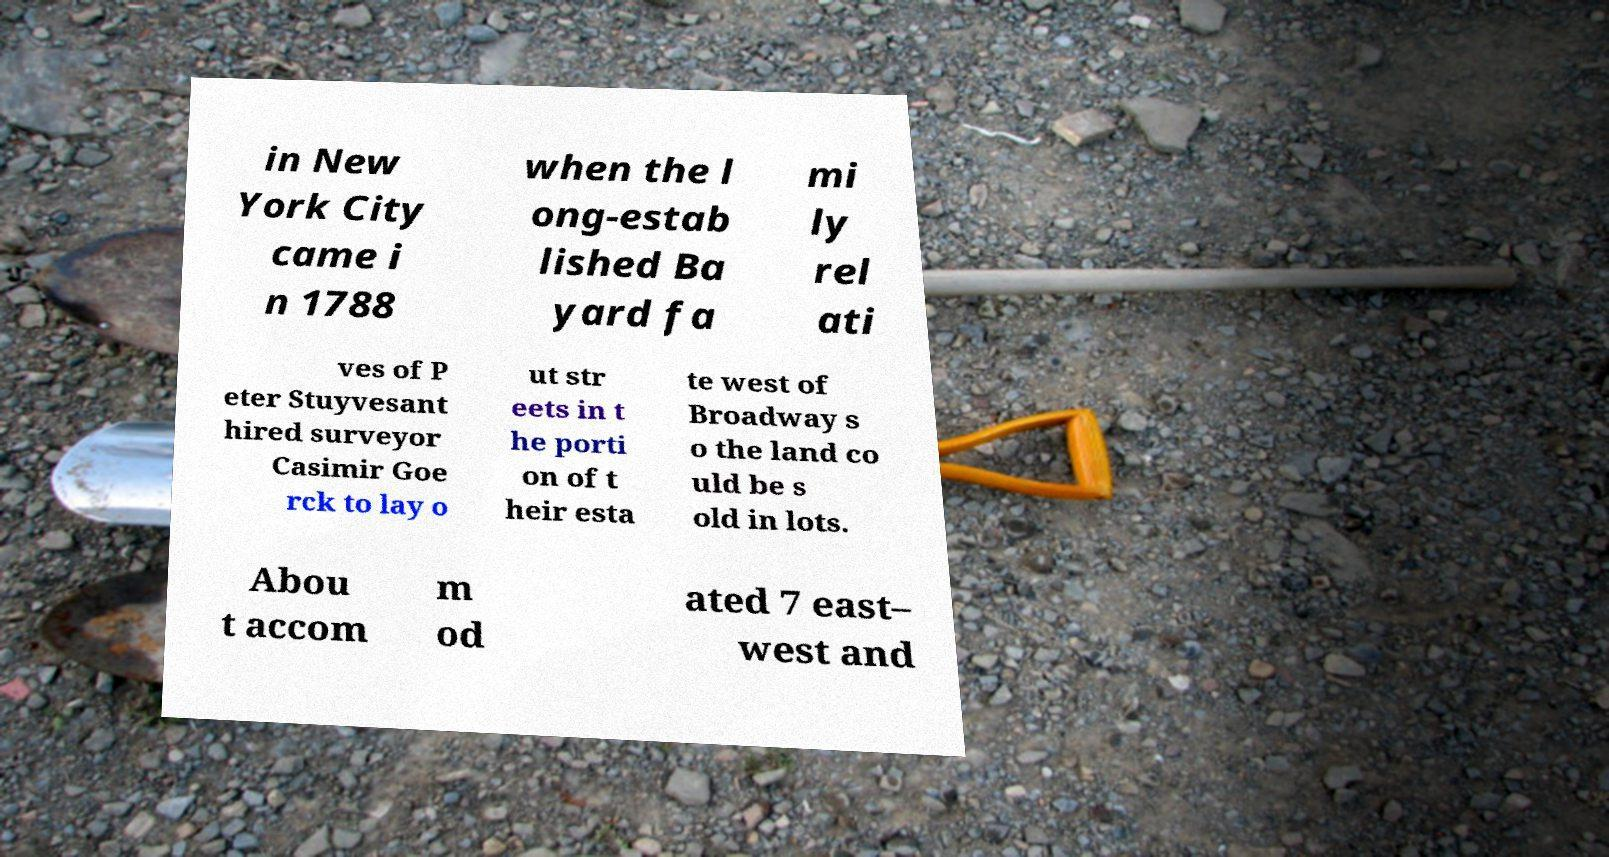Please read and relay the text visible in this image. What does it say? in New York City came i n 1788 when the l ong-estab lished Ba yard fa mi ly rel ati ves of P eter Stuyvesant hired surveyor Casimir Goe rck to lay o ut str eets in t he porti on of t heir esta te west of Broadway s o the land co uld be s old in lots. Abou t accom m od ated 7 east– west and 